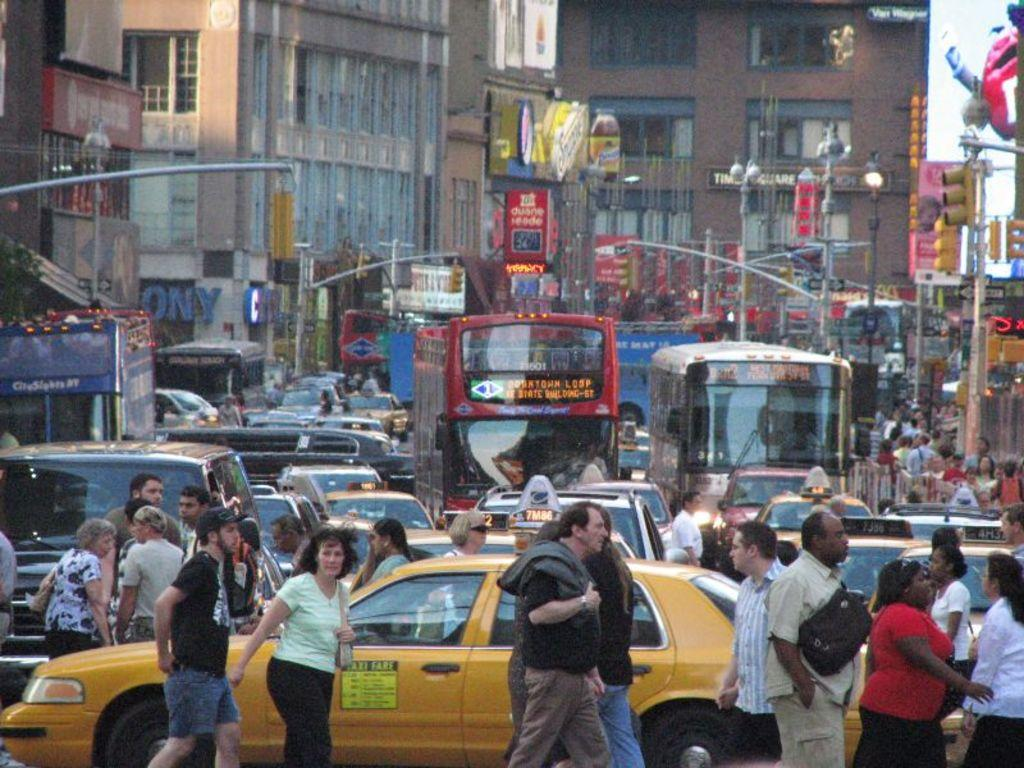What type of location is depicted in the image? The image shows a street. What structures can be seen along the street? There are buildings in the street. What types of vehicles are present in the image? There are buses and cars in the street. Are there any people visible in the image? Yes, there are people in the street. What can be seen in the sky in the image? The sky is visible in the image. What traffic control devices are present in the image? There are traffic lights and street lights in the image. Where is the cave located in the image? There is no cave present in the image. What type of lamp is hanging from the rod in the image? There is no lamp or rod present in the image. 